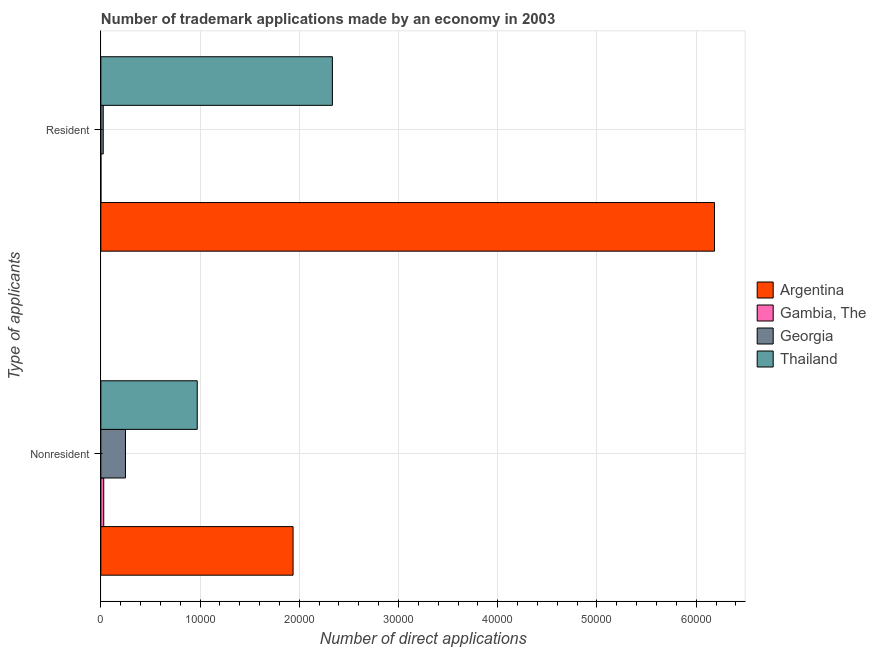How many bars are there on the 1st tick from the bottom?
Your response must be concise. 4. What is the label of the 1st group of bars from the top?
Your answer should be compact. Resident. What is the number of trademark applications made by non residents in Argentina?
Your answer should be very brief. 1.94e+04. Across all countries, what is the maximum number of trademark applications made by residents?
Provide a short and direct response. 6.18e+04. Across all countries, what is the minimum number of trademark applications made by non residents?
Provide a short and direct response. 291. In which country was the number of trademark applications made by residents minimum?
Offer a very short reply. Gambia, The. What is the total number of trademark applications made by non residents in the graph?
Offer a very short reply. 3.19e+04. What is the difference between the number of trademark applications made by non residents in Gambia, The and that in Georgia?
Provide a succinct answer. -2190. What is the difference between the number of trademark applications made by non residents in Thailand and the number of trademark applications made by residents in Argentina?
Offer a very short reply. -5.21e+04. What is the average number of trademark applications made by residents per country?
Make the answer very short. 2.14e+04. What is the difference between the number of trademark applications made by residents and number of trademark applications made by non residents in Thailand?
Your response must be concise. 1.36e+04. What is the ratio of the number of trademark applications made by non residents in Gambia, The to that in Georgia?
Offer a very short reply. 0.12. What does the 4th bar from the top in Resident represents?
Ensure brevity in your answer.  Argentina. What does the 3rd bar from the bottom in Resident represents?
Provide a short and direct response. Georgia. Are the values on the major ticks of X-axis written in scientific E-notation?
Make the answer very short. No. Does the graph contain any zero values?
Keep it short and to the point. No. Does the graph contain grids?
Offer a very short reply. Yes. How many legend labels are there?
Keep it short and to the point. 4. How are the legend labels stacked?
Your answer should be very brief. Vertical. What is the title of the graph?
Your answer should be very brief. Number of trademark applications made by an economy in 2003. What is the label or title of the X-axis?
Your answer should be compact. Number of direct applications. What is the label or title of the Y-axis?
Ensure brevity in your answer.  Type of applicants. What is the Number of direct applications of Argentina in Nonresident?
Provide a short and direct response. 1.94e+04. What is the Number of direct applications in Gambia, The in Nonresident?
Offer a very short reply. 291. What is the Number of direct applications of Georgia in Nonresident?
Offer a terse response. 2481. What is the Number of direct applications in Thailand in Nonresident?
Offer a terse response. 9714. What is the Number of direct applications in Argentina in Resident?
Provide a short and direct response. 6.18e+04. What is the Number of direct applications in Gambia, The in Resident?
Offer a very short reply. 7. What is the Number of direct applications of Georgia in Resident?
Keep it short and to the point. 241. What is the Number of direct applications in Thailand in Resident?
Offer a very short reply. 2.33e+04. Across all Type of applicants, what is the maximum Number of direct applications in Argentina?
Your answer should be compact. 6.18e+04. Across all Type of applicants, what is the maximum Number of direct applications of Gambia, The?
Keep it short and to the point. 291. Across all Type of applicants, what is the maximum Number of direct applications of Georgia?
Offer a terse response. 2481. Across all Type of applicants, what is the maximum Number of direct applications in Thailand?
Keep it short and to the point. 2.33e+04. Across all Type of applicants, what is the minimum Number of direct applications in Argentina?
Offer a terse response. 1.94e+04. Across all Type of applicants, what is the minimum Number of direct applications in Georgia?
Ensure brevity in your answer.  241. Across all Type of applicants, what is the minimum Number of direct applications in Thailand?
Provide a succinct answer. 9714. What is the total Number of direct applications of Argentina in the graph?
Offer a terse response. 8.12e+04. What is the total Number of direct applications in Gambia, The in the graph?
Provide a succinct answer. 298. What is the total Number of direct applications of Georgia in the graph?
Keep it short and to the point. 2722. What is the total Number of direct applications in Thailand in the graph?
Offer a terse response. 3.30e+04. What is the difference between the Number of direct applications of Argentina in Nonresident and that in Resident?
Ensure brevity in your answer.  -4.25e+04. What is the difference between the Number of direct applications of Gambia, The in Nonresident and that in Resident?
Offer a terse response. 284. What is the difference between the Number of direct applications in Georgia in Nonresident and that in Resident?
Offer a terse response. 2240. What is the difference between the Number of direct applications in Thailand in Nonresident and that in Resident?
Give a very brief answer. -1.36e+04. What is the difference between the Number of direct applications in Argentina in Nonresident and the Number of direct applications in Gambia, The in Resident?
Make the answer very short. 1.94e+04. What is the difference between the Number of direct applications of Argentina in Nonresident and the Number of direct applications of Georgia in Resident?
Your answer should be compact. 1.91e+04. What is the difference between the Number of direct applications in Argentina in Nonresident and the Number of direct applications in Thailand in Resident?
Offer a very short reply. -3962. What is the difference between the Number of direct applications of Gambia, The in Nonresident and the Number of direct applications of Georgia in Resident?
Provide a short and direct response. 50. What is the difference between the Number of direct applications of Gambia, The in Nonresident and the Number of direct applications of Thailand in Resident?
Ensure brevity in your answer.  -2.30e+04. What is the difference between the Number of direct applications of Georgia in Nonresident and the Number of direct applications of Thailand in Resident?
Your answer should be very brief. -2.09e+04. What is the average Number of direct applications of Argentina per Type of applicants?
Offer a very short reply. 4.06e+04. What is the average Number of direct applications in Gambia, The per Type of applicants?
Offer a very short reply. 149. What is the average Number of direct applications in Georgia per Type of applicants?
Make the answer very short. 1361. What is the average Number of direct applications in Thailand per Type of applicants?
Provide a succinct answer. 1.65e+04. What is the difference between the Number of direct applications of Argentina and Number of direct applications of Gambia, The in Nonresident?
Make the answer very short. 1.91e+04. What is the difference between the Number of direct applications in Argentina and Number of direct applications in Georgia in Nonresident?
Provide a succinct answer. 1.69e+04. What is the difference between the Number of direct applications of Argentina and Number of direct applications of Thailand in Nonresident?
Provide a short and direct response. 9659. What is the difference between the Number of direct applications in Gambia, The and Number of direct applications in Georgia in Nonresident?
Offer a terse response. -2190. What is the difference between the Number of direct applications in Gambia, The and Number of direct applications in Thailand in Nonresident?
Your answer should be very brief. -9423. What is the difference between the Number of direct applications in Georgia and Number of direct applications in Thailand in Nonresident?
Offer a very short reply. -7233. What is the difference between the Number of direct applications in Argentina and Number of direct applications in Gambia, The in Resident?
Your response must be concise. 6.18e+04. What is the difference between the Number of direct applications in Argentina and Number of direct applications in Georgia in Resident?
Your response must be concise. 6.16e+04. What is the difference between the Number of direct applications of Argentina and Number of direct applications of Thailand in Resident?
Provide a short and direct response. 3.85e+04. What is the difference between the Number of direct applications in Gambia, The and Number of direct applications in Georgia in Resident?
Offer a very short reply. -234. What is the difference between the Number of direct applications of Gambia, The and Number of direct applications of Thailand in Resident?
Offer a very short reply. -2.33e+04. What is the difference between the Number of direct applications of Georgia and Number of direct applications of Thailand in Resident?
Offer a terse response. -2.31e+04. What is the ratio of the Number of direct applications in Argentina in Nonresident to that in Resident?
Provide a succinct answer. 0.31. What is the ratio of the Number of direct applications in Gambia, The in Nonresident to that in Resident?
Provide a short and direct response. 41.57. What is the ratio of the Number of direct applications in Georgia in Nonresident to that in Resident?
Make the answer very short. 10.29. What is the ratio of the Number of direct applications of Thailand in Nonresident to that in Resident?
Your response must be concise. 0.42. What is the difference between the highest and the second highest Number of direct applications of Argentina?
Your answer should be very brief. 4.25e+04. What is the difference between the highest and the second highest Number of direct applications in Gambia, The?
Keep it short and to the point. 284. What is the difference between the highest and the second highest Number of direct applications of Georgia?
Provide a succinct answer. 2240. What is the difference between the highest and the second highest Number of direct applications in Thailand?
Make the answer very short. 1.36e+04. What is the difference between the highest and the lowest Number of direct applications in Argentina?
Make the answer very short. 4.25e+04. What is the difference between the highest and the lowest Number of direct applications in Gambia, The?
Provide a succinct answer. 284. What is the difference between the highest and the lowest Number of direct applications in Georgia?
Give a very brief answer. 2240. What is the difference between the highest and the lowest Number of direct applications in Thailand?
Provide a short and direct response. 1.36e+04. 